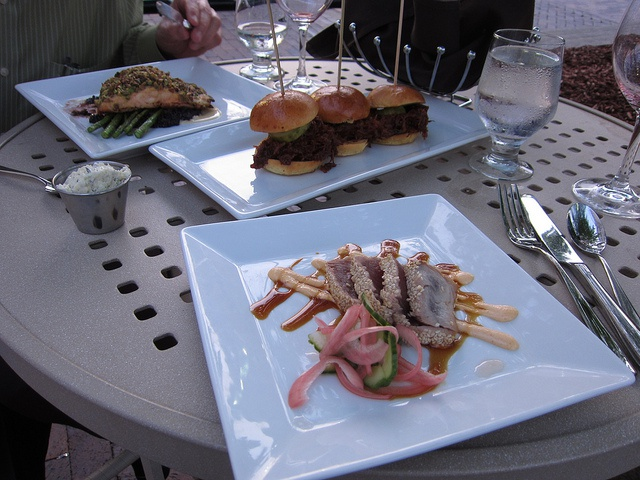Describe the objects in this image and their specific colors. I can see dining table in black, darkgray, and gray tones, people in black, gray, maroon, and brown tones, wine glass in black and gray tones, sandwich in black, gray, and maroon tones, and sandwich in black, maroon, and brown tones in this image. 